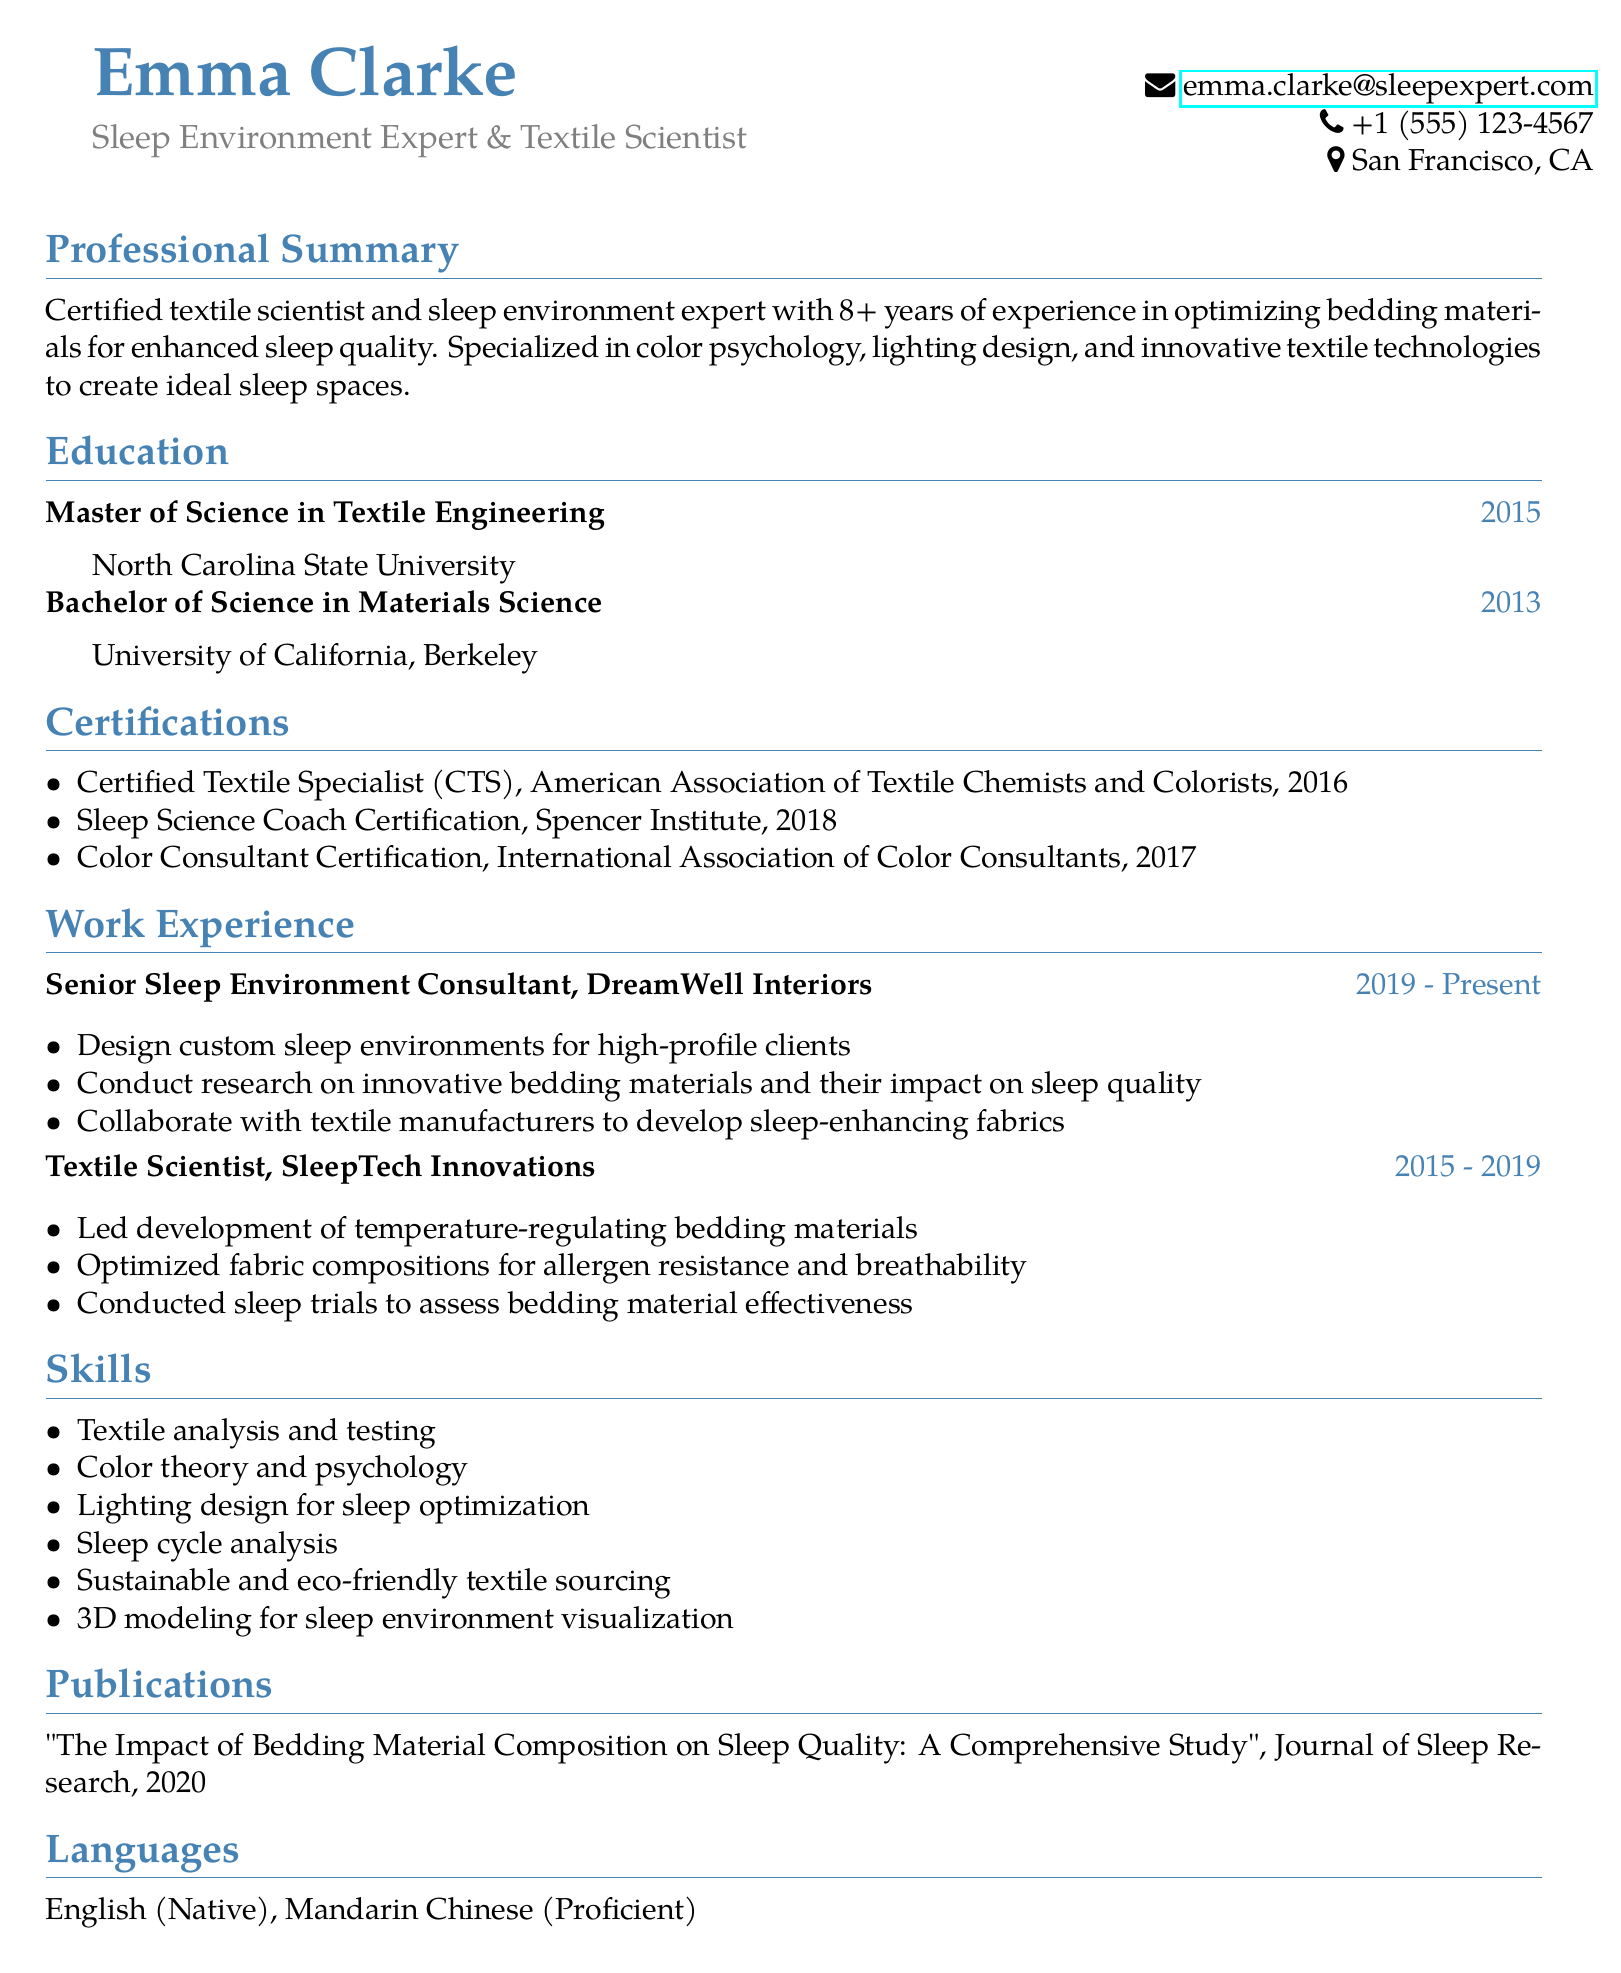What is Emma Clarke's email address? The email address is listed under her personal information section in the CV.
Answer: emma.clarke@sleepexpert.com What certification was issued by the Spencer Institute? The document lists the certifications obtained by Emma Clarke, including those from various organizations.
Answer: Sleep Science Coach Certification In which year did Emma complete her Master’s degree? The education section specifies the years in which degrees were acquired.
Answer: 2015 What is the title of Emma's publication? The publications section includes details about her published work.
Answer: The Impact of Bedding Material Composition on Sleep Quality: A Comprehensive Study How many years of experience does Emma have in optimizing bedding materials? The professional summary mentions her years of experience in the field.
Answer: 8+ Which skills are listed related to lighting design? The skills section outlines specific proficiencies that Emma possesses relevant to her expertise.
Answer: Lighting design for sleep optimization What role does Emma currently hold? The work experience section indicates her current job title and associations.
Answer: Senior Sleep Environment Consultant Which university did Emma Clarke attend for her Bachelor's degree? The education section provides information about the institutions where she studied.
Answer: University of California, Berkeley What language is listed as proficient other than English? The languages section indicates Emma’s language skills, detailing her proficiency levels.
Answer: Mandarin Chinese 